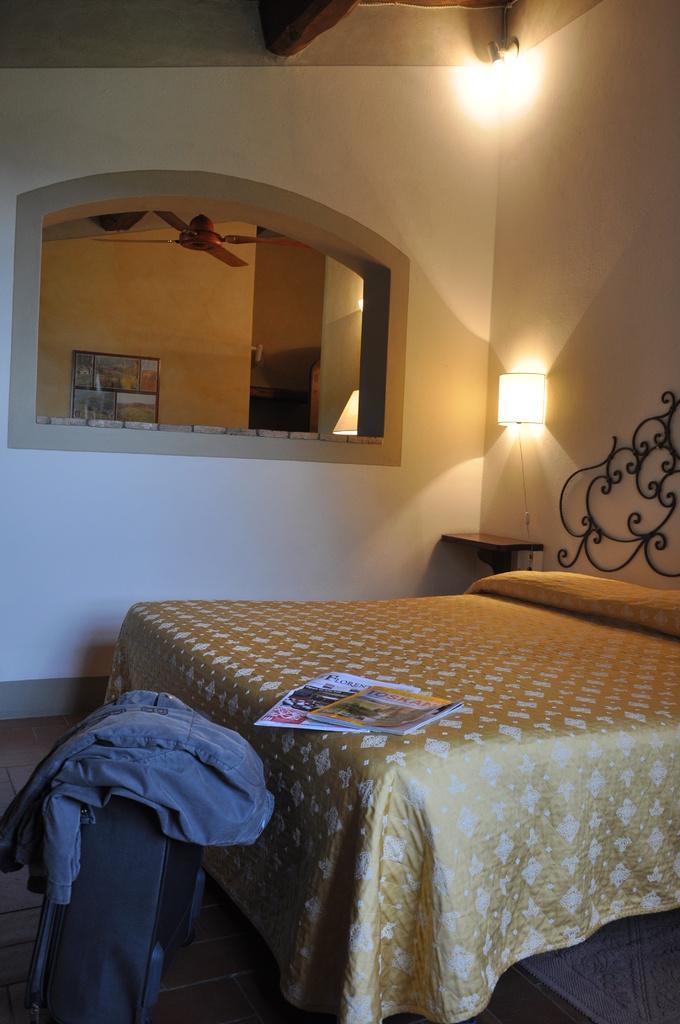Please provide a concise description of this image. This image consists of a bedroom. In the front, we can see a bed on which we can see a book and papers. On the left, it looks like a suitcase. On which we can see a coat. In the background, there is a window through which we can see a fan and a photo frame hanged on the wall. On the right, there are lamps. 